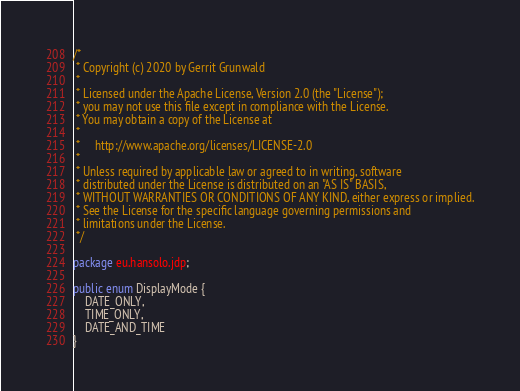Convert code to text. <code><loc_0><loc_0><loc_500><loc_500><_Java_>/*
 * Copyright (c) 2020 by Gerrit Grunwald
 *
 * Licensed under the Apache License, Version 2.0 (the "License");
 * you may not use this file except in compliance with the License.
 * You may obtain a copy of the License at
 *
 *     http://www.apache.org/licenses/LICENSE-2.0
 *
 * Unless required by applicable law or agreed to in writing, software
 * distributed under the License is distributed on an "AS IS" BASIS,
 * WITHOUT WARRANTIES OR CONDITIONS OF ANY KIND, either express or implied.
 * See the License for the specific language governing permissions and
 * limitations under the License.
 */

package eu.hansolo.jdp;

public enum DisplayMode {
    DATE_ONLY,
    TIME_ONLY,
    DATE_AND_TIME
}
</code> 